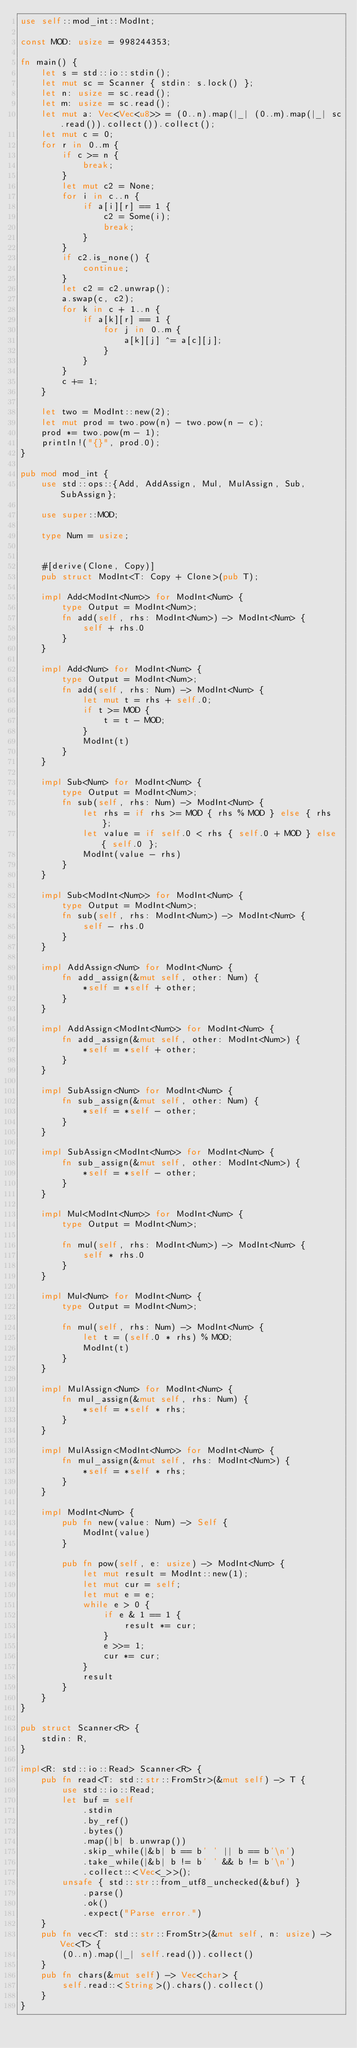<code> <loc_0><loc_0><loc_500><loc_500><_Rust_>use self::mod_int::ModInt;

const MOD: usize = 998244353;

fn main() {
    let s = std::io::stdin();
    let mut sc = Scanner { stdin: s.lock() };
    let n: usize = sc.read();
    let m: usize = sc.read();
    let mut a: Vec<Vec<u8>> = (0..n).map(|_| (0..m).map(|_| sc.read()).collect()).collect();
    let mut c = 0;
    for r in 0..m {
        if c >= n {
            break;
        }
        let mut c2 = None;
        for i in c..n {
            if a[i][r] == 1 {
                c2 = Some(i);
                break;
            }
        }
        if c2.is_none() {
            continue;
        }
        let c2 = c2.unwrap();
        a.swap(c, c2);
        for k in c + 1..n {
            if a[k][r] == 1 {
                for j in 0..m {
                    a[k][j] ^= a[c][j];
                }
            }
        }
        c += 1;
    }

    let two = ModInt::new(2);
    let mut prod = two.pow(n) - two.pow(n - c);
    prod *= two.pow(m - 1);
    println!("{}", prod.0);
}

pub mod mod_int {
    use std::ops::{Add, AddAssign, Mul, MulAssign, Sub, SubAssign};

    use super::MOD;

    type Num = usize;


    #[derive(Clone, Copy)]
    pub struct ModInt<T: Copy + Clone>(pub T);

    impl Add<ModInt<Num>> for ModInt<Num> {
        type Output = ModInt<Num>;
        fn add(self, rhs: ModInt<Num>) -> ModInt<Num> {
            self + rhs.0
        }
    }

    impl Add<Num> for ModInt<Num> {
        type Output = ModInt<Num>;
        fn add(self, rhs: Num) -> ModInt<Num> {
            let mut t = rhs + self.0;
            if t >= MOD {
                t = t - MOD;
            }
            ModInt(t)
        }
    }

    impl Sub<Num> for ModInt<Num> {
        type Output = ModInt<Num>;
        fn sub(self, rhs: Num) -> ModInt<Num> {
            let rhs = if rhs >= MOD { rhs % MOD } else { rhs };
            let value = if self.0 < rhs { self.0 + MOD } else { self.0 };
            ModInt(value - rhs)
        }
    }

    impl Sub<ModInt<Num>> for ModInt<Num> {
        type Output = ModInt<Num>;
        fn sub(self, rhs: ModInt<Num>) -> ModInt<Num> {
            self - rhs.0
        }
    }

    impl AddAssign<Num> for ModInt<Num> {
        fn add_assign(&mut self, other: Num) {
            *self = *self + other;
        }
    }

    impl AddAssign<ModInt<Num>> for ModInt<Num> {
        fn add_assign(&mut self, other: ModInt<Num>) {
            *self = *self + other;
        }
    }

    impl SubAssign<Num> for ModInt<Num> {
        fn sub_assign(&mut self, other: Num) {
            *self = *self - other;
        }
    }

    impl SubAssign<ModInt<Num>> for ModInt<Num> {
        fn sub_assign(&mut self, other: ModInt<Num>) {
            *self = *self - other;
        }
    }

    impl Mul<ModInt<Num>> for ModInt<Num> {
        type Output = ModInt<Num>;

        fn mul(self, rhs: ModInt<Num>) -> ModInt<Num> {
            self * rhs.0
        }
    }

    impl Mul<Num> for ModInt<Num> {
        type Output = ModInt<Num>;

        fn mul(self, rhs: Num) -> ModInt<Num> {
            let t = (self.0 * rhs) % MOD;
            ModInt(t)
        }
    }

    impl MulAssign<Num> for ModInt<Num> {
        fn mul_assign(&mut self, rhs: Num) {
            *self = *self * rhs;
        }
    }

    impl MulAssign<ModInt<Num>> for ModInt<Num> {
        fn mul_assign(&mut self, rhs: ModInt<Num>) {
            *self = *self * rhs;
        }
    }

    impl ModInt<Num> {
        pub fn new(value: Num) -> Self {
            ModInt(value)
        }

        pub fn pow(self, e: usize) -> ModInt<Num> {
            let mut result = ModInt::new(1);
            let mut cur = self;
            let mut e = e;
            while e > 0 {
                if e & 1 == 1 {
                    result *= cur;
                }
                e >>= 1;
                cur *= cur;
            }
            result
        }
    }
}

pub struct Scanner<R> {
    stdin: R,
}

impl<R: std::io::Read> Scanner<R> {
    pub fn read<T: std::str::FromStr>(&mut self) -> T {
        use std::io::Read;
        let buf = self
            .stdin
            .by_ref()
            .bytes()
            .map(|b| b.unwrap())
            .skip_while(|&b| b == b' ' || b == b'\n')
            .take_while(|&b| b != b' ' && b != b'\n')
            .collect::<Vec<_>>();
        unsafe { std::str::from_utf8_unchecked(&buf) }
            .parse()
            .ok()
            .expect("Parse error.")
    }
    pub fn vec<T: std::str::FromStr>(&mut self, n: usize) -> Vec<T> {
        (0..n).map(|_| self.read()).collect()
    }
    pub fn chars(&mut self) -> Vec<char> {
        self.read::<String>().chars().collect()
    }
}
</code> 